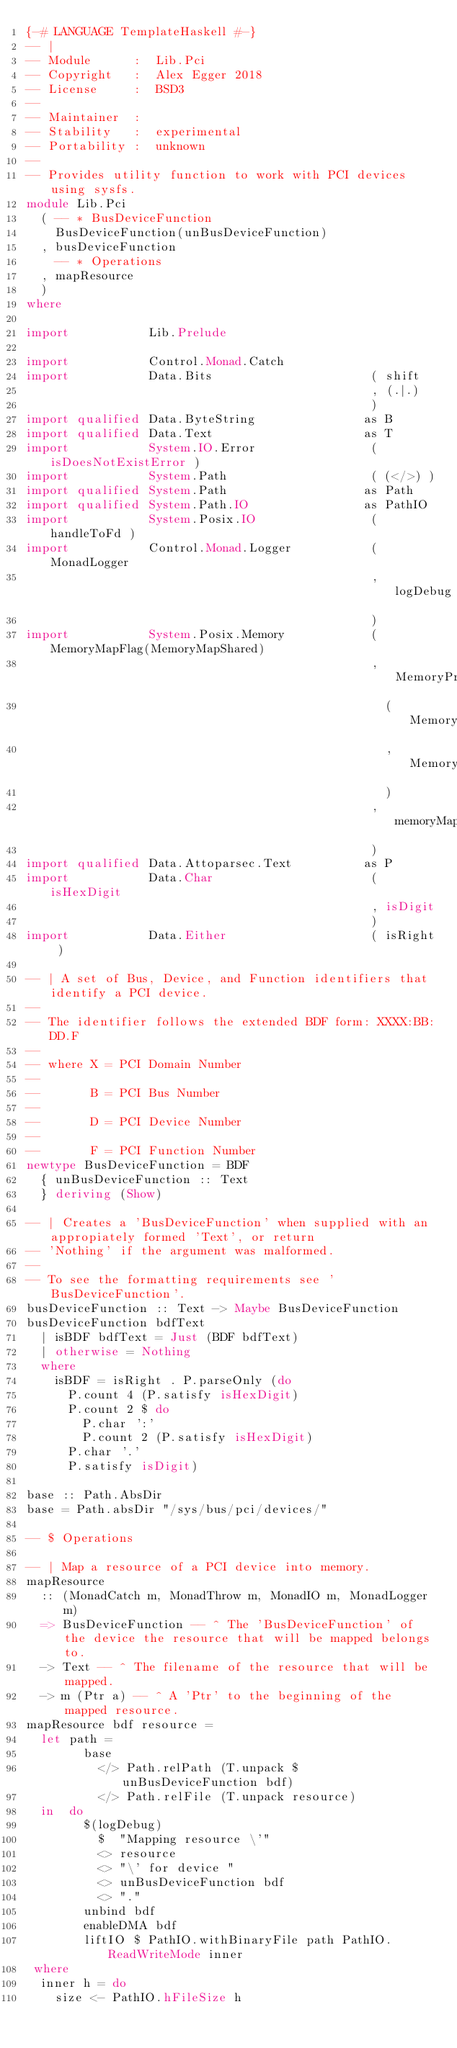Convert code to text. <code><loc_0><loc_0><loc_500><loc_500><_Haskell_>{-# LANGUAGE TemplateHaskell #-}
-- |
-- Module      :  Lib.Pci
-- Copyright   :  Alex Egger 2018
-- License     :  BSD3
--
-- Maintainer  :
-- Stability   :  experimental
-- Portability :  unknown
--
-- Provides utility function to work with PCI devices using sysfs.
module Lib.Pci
  ( -- * BusDeviceFunction
    BusDeviceFunction(unBusDeviceFunction)
  , busDeviceFunction
    -- * Operations
  , mapResource
  )
where

import           Lib.Prelude

import           Control.Monad.Catch
import           Data.Bits                      ( shift
                                                , (.|.)
                                                )
import qualified Data.ByteString               as B
import qualified Data.Text                     as T
import           System.IO.Error                ( isDoesNotExistError )
import           System.Path                    ( (</>) )
import qualified System.Path                   as Path
import qualified System.Path.IO                as PathIO
import           System.Posix.IO                ( handleToFd )
import           Control.Monad.Logger           ( MonadLogger
                                                , logDebug
                                                )
import           System.Posix.Memory            ( MemoryMapFlag(MemoryMapShared)
                                                , MemoryProtection
                                                  ( MemoryProtectionRead
                                                  , MemoryProtectionWrite
                                                  )
                                                , memoryMap
                                                )
import qualified Data.Attoparsec.Text          as P
import           Data.Char                      ( isHexDigit
                                                , isDigit
                                                )
import           Data.Either                    ( isRight )

-- | A set of Bus, Device, and Function identifiers that identify a PCI device.
--
-- The identifier follows the extended BDF form: XXXX:BB:DD.F
--
-- where X = PCI Domain Number
--
--       B = PCI Bus Number
--
--       D = PCI Device Number
--
--       F = PCI Function Number
newtype BusDeviceFunction = BDF
  { unBusDeviceFunction :: Text
  } deriving (Show)

-- | Creates a 'BusDeviceFunction' when supplied with an appropiately formed 'Text', or return
-- 'Nothing' if the argument was malformed.
--
-- To see the formatting requirements see 'BusDeviceFunction'.
busDeviceFunction :: Text -> Maybe BusDeviceFunction
busDeviceFunction bdfText
  | isBDF bdfText = Just (BDF bdfText)
  | otherwise = Nothing
  where
    isBDF = isRight . P.parseOnly (do
      P.count 4 (P.satisfy isHexDigit)
      P.count 2 $ do
        P.char ':'
        P.count 2 (P.satisfy isHexDigit)
      P.char '.'
      P.satisfy isDigit)

base :: Path.AbsDir
base = Path.absDir "/sys/bus/pci/devices/"

-- $ Operations

-- | Map a resource of a PCI device into memory.
mapResource
  :: (MonadCatch m, MonadThrow m, MonadIO m, MonadLogger m)
  => BusDeviceFunction -- ^ The 'BusDeviceFunction' of the device the resource that will be mapped belongs to.
  -> Text -- ^ The filename of the resource that will be mapped.
  -> m (Ptr a) -- ^ A 'Ptr' to the beginning of the mapped resource.
mapResource bdf resource =
  let path =
        base
          </> Path.relPath (T.unpack $ unBusDeviceFunction bdf)
          </> Path.relFile (T.unpack resource)
  in  do
        $(logDebug)
          $  "Mapping resource \'"
          <> resource
          <> "\' for device "
          <> unBusDeviceFunction bdf
          <> "."
        unbind bdf
        enableDMA bdf
        liftIO $ PathIO.withBinaryFile path PathIO.ReadWriteMode inner
 where
  inner h = do
    size <- PathIO.hFileSize h</code> 